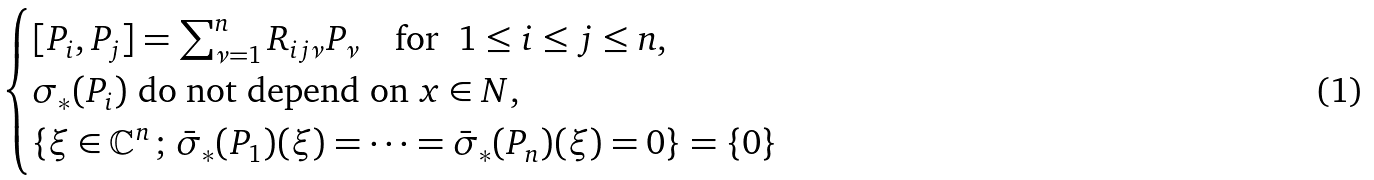<formula> <loc_0><loc_0><loc_500><loc_500>\begin{cases} [ P _ { i } , P _ { j } ] = \sum _ { \nu = 1 } ^ { n } R _ { i j \nu } P _ { \nu } \quad \text {for \ } 1 \leq i \leq j \leq n , \\ \sigma _ { * } ( P _ { i } ) \text { do not depend on } x \in N , \\ \{ \xi \in \mathbb { C } ^ { n } \, ; \, \bar { \sigma } _ { * } ( P _ { 1 } ) ( \xi ) = \cdots = \bar { \sigma } _ { * } ( P _ { n } ) ( \xi ) = 0 \} = \{ 0 \} \end{cases}</formula> 